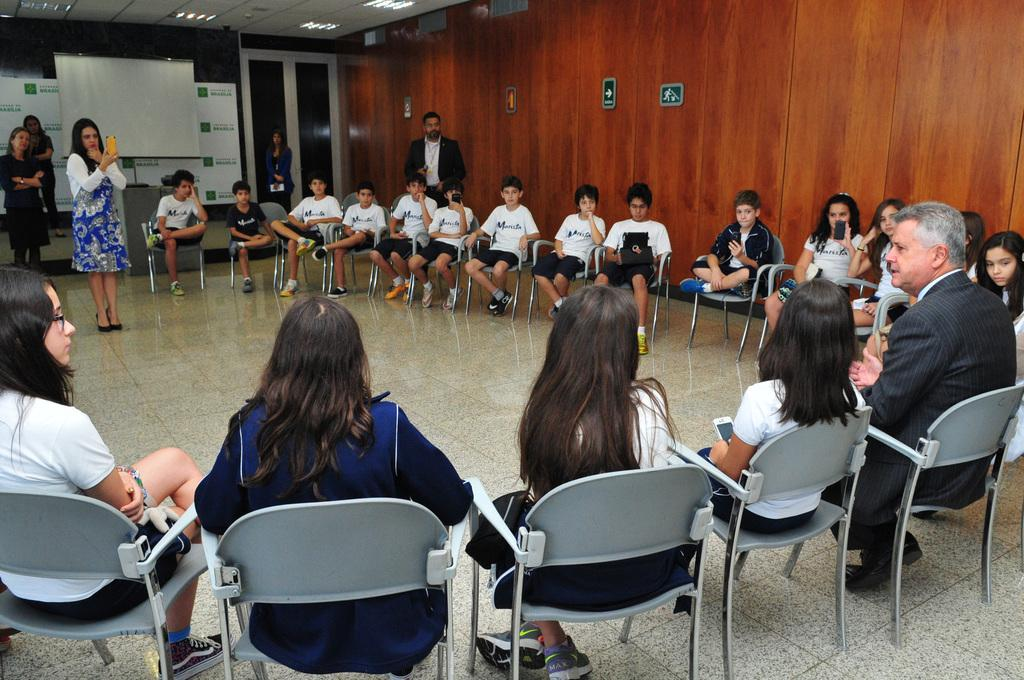What are the people in the image doing? The people in the image are sitting in chairs in a row. Who is capturing the scene in the image? A lady is capturing the scene using her phone. What is the position of the man in the image? There is a man standing behind the lady. What device is present in the image for displaying content? There is a projector present. What type of coal is being distributed in the middle of the image? There is no coal or distribution present in the image. What is the middle position of the lady in the image? The lady is not in the middle of the image; she is capturing the scene using her phone. 